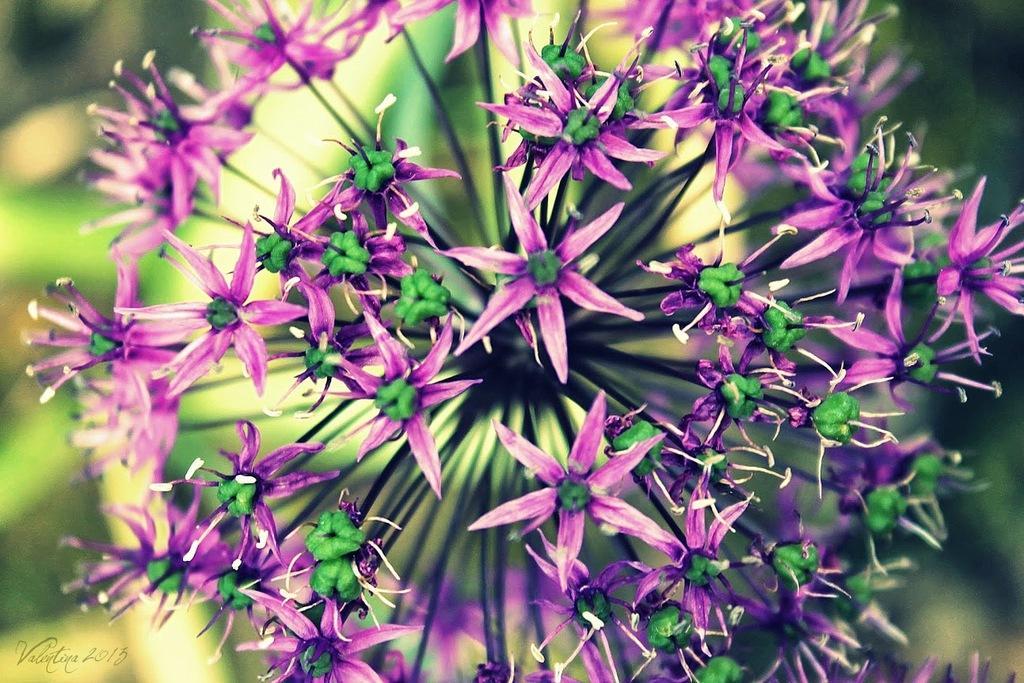In one or two sentences, can you explain what this image depicts? Here in this picture we can see flowers present on a plant and we can see the background is in blurry manner. 